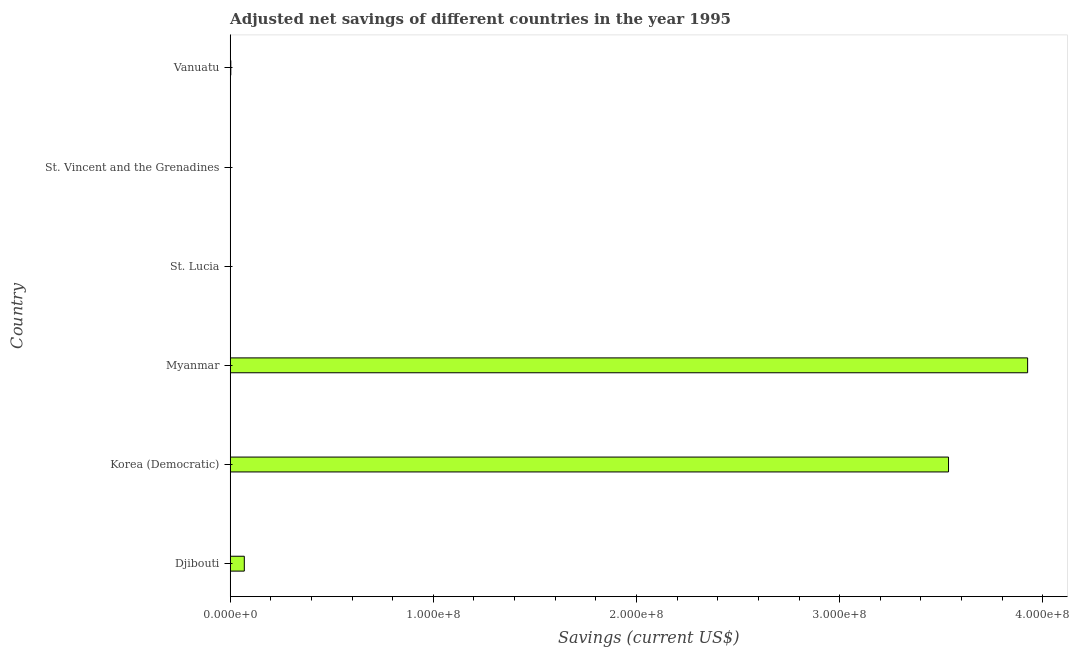What is the title of the graph?
Provide a succinct answer. Adjusted net savings of different countries in the year 1995. What is the label or title of the X-axis?
Keep it short and to the point. Savings (current US$). What is the adjusted net savings in Vanuatu?
Provide a short and direct response. 3.05e+05. Across all countries, what is the maximum adjusted net savings?
Ensure brevity in your answer.  3.93e+08. Across all countries, what is the minimum adjusted net savings?
Ensure brevity in your answer.  1692.48. In which country was the adjusted net savings maximum?
Offer a terse response. Myanmar. In which country was the adjusted net savings minimum?
Your answer should be compact. St. Lucia. What is the sum of the adjusted net savings?
Provide a succinct answer. 7.53e+08. What is the difference between the adjusted net savings in Djibouti and Myanmar?
Provide a short and direct response. -3.86e+08. What is the average adjusted net savings per country?
Your answer should be compact. 1.26e+08. What is the median adjusted net savings?
Offer a terse response. 3.63e+06. What is the ratio of the adjusted net savings in Djibouti to that in Korea (Democratic)?
Keep it short and to the point. 0.02. What is the difference between the highest and the second highest adjusted net savings?
Make the answer very short. 3.89e+07. What is the difference between the highest and the lowest adjusted net savings?
Give a very brief answer. 3.93e+08. How many bars are there?
Your answer should be very brief. 6. Are the values on the major ticks of X-axis written in scientific E-notation?
Your response must be concise. Yes. What is the Savings (current US$) of Djibouti?
Provide a succinct answer. 6.95e+06. What is the Savings (current US$) in Korea (Democratic)?
Provide a succinct answer. 3.54e+08. What is the Savings (current US$) in Myanmar?
Your response must be concise. 3.93e+08. What is the Savings (current US$) of St. Lucia?
Make the answer very short. 1692.48. What is the Savings (current US$) in St. Vincent and the Grenadines?
Make the answer very short. 9.90e+04. What is the Savings (current US$) in Vanuatu?
Provide a succinct answer. 3.05e+05. What is the difference between the Savings (current US$) in Djibouti and Korea (Democratic)?
Offer a terse response. -3.47e+08. What is the difference between the Savings (current US$) in Djibouti and Myanmar?
Make the answer very short. -3.86e+08. What is the difference between the Savings (current US$) in Djibouti and St. Lucia?
Give a very brief answer. 6.95e+06. What is the difference between the Savings (current US$) in Djibouti and St. Vincent and the Grenadines?
Offer a terse response. 6.85e+06. What is the difference between the Savings (current US$) in Djibouti and Vanuatu?
Your answer should be compact. 6.65e+06. What is the difference between the Savings (current US$) in Korea (Democratic) and Myanmar?
Provide a succinct answer. -3.89e+07. What is the difference between the Savings (current US$) in Korea (Democratic) and St. Lucia?
Ensure brevity in your answer.  3.54e+08. What is the difference between the Savings (current US$) in Korea (Democratic) and St. Vincent and the Grenadines?
Offer a terse response. 3.53e+08. What is the difference between the Savings (current US$) in Korea (Democratic) and Vanuatu?
Make the answer very short. 3.53e+08. What is the difference between the Savings (current US$) in Myanmar and St. Lucia?
Offer a terse response. 3.93e+08. What is the difference between the Savings (current US$) in Myanmar and St. Vincent and the Grenadines?
Provide a succinct answer. 3.92e+08. What is the difference between the Savings (current US$) in Myanmar and Vanuatu?
Your answer should be very brief. 3.92e+08. What is the difference between the Savings (current US$) in St. Lucia and St. Vincent and the Grenadines?
Provide a short and direct response. -9.73e+04. What is the difference between the Savings (current US$) in St. Lucia and Vanuatu?
Keep it short and to the point. -3.03e+05. What is the difference between the Savings (current US$) in St. Vincent and the Grenadines and Vanuatu?
Your response must be concise. -2.06e+05. What is the ratio of the Savings (current US$) in Djibouti to that in Myanmar?
Offer a terse response. 0.02. What is the ratio of the Savings (current US$) in Djibouti to that in St. Lucia?
Keep it short and to the point. 4107.19. What is the ratio of the Savings (current US$) in Djibouti to that in St. Vincent and the Grenadines?
Provide a succinct answer. 70.19. What is the ratio of the Savings (current US$) in Djibouti to that in Vanuatu?
Your response must be concise. 22.81. What is the ratio of the Savings (current US$) in Korea (Democratic) to that in Myanmar?
Keep it short and to the point. 0.9. What is the ratio of the Savings (current US$) in Korea (Democratic) to that in St. Lucia?
Make the answer very short. 2.09e+05. What is the ratio of the Savings (current US$) in Korea (Democratic) to that in St. Vincent and the Grenadines?
Your answer should be very brief. 3570.51. What is the ratio of the Savings (current US$) in Korea (Democratic) to that in Vanuatu?
Provide a short and direct response. 1160.23. What is the ratio of the Savings (current US$) in Myanmar to that in St. Lucia?
Offer a very short reply. 2.32e+05. What is the ratio of the Savings (current US$) in Myanmar to that in St. Vincent and the Grenadines?
Ensure brevity in your answer.  3963.59. What is the ratio of the Savings (current US$) in Myanmar to that in Vanuatu?
Give a very brief answer. 1287.96. What is the ratio of the Savings (current US$) in St. Lucia to that in St. Vincent and the Grenadines?
Your answer should be very brief. 0.02. What is the ratio of the Savings (current US$) in St. Lucia to that in Vanuatu?
Make the answer very short. 0.01. What is the ratio of the Savings (current US$) in St. Vincent and the Grenadines to that in Vanuatu?
Ensure brevity in your answer.  0.33. 